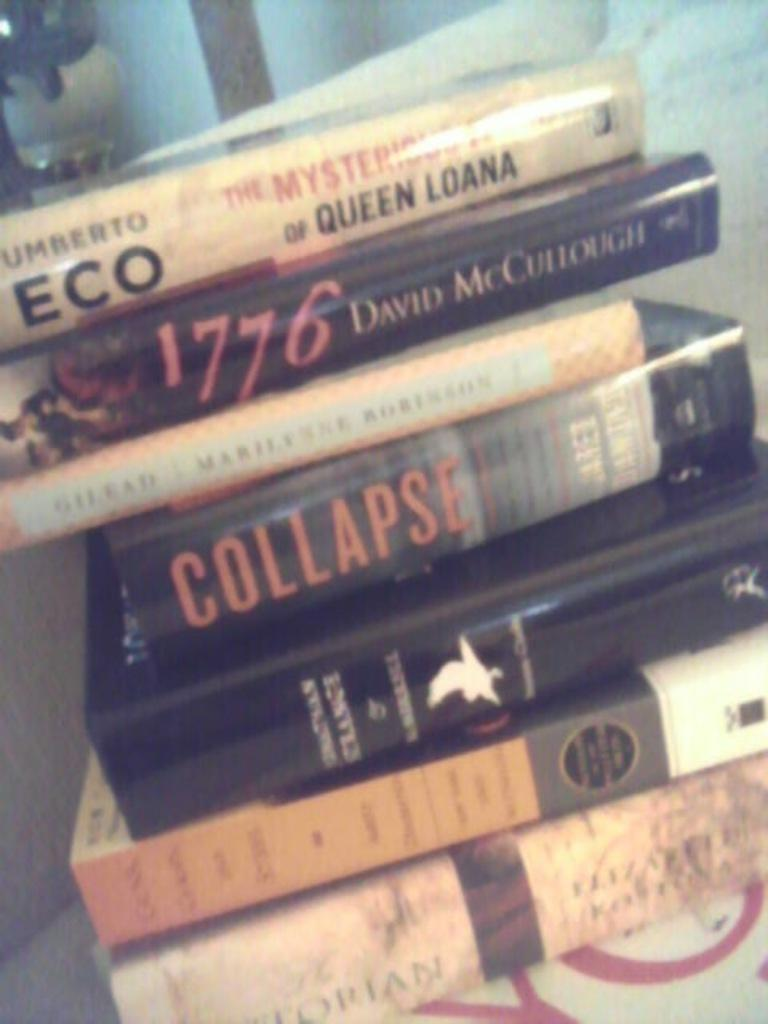<image>
Offer a succinct explanation of the picture presented. a stack of books with one of them titled 'collapse' 